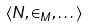Convert formula to latex. <formula><loc_0><loc_0><loc_500><loc_500>\langle N , \in _ { M } , \dots \rangle</formula> 